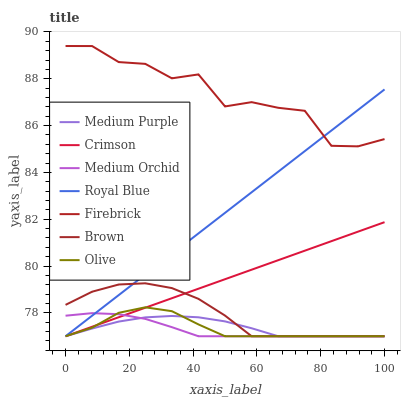Does Medium Orchid have the minimum area under the curve?
Answer yes or no. Yes. Does Firebrick have the maximum area under the curve?
Answer yes or no. Yes. Does Olive have the minimum area under the curve?
Answer yes or no. No. Does Olive have the maximum area under the curve?
Answer yes or no. No. Is Royal Blue the smoothest?
Answer yes or no. Yes. Is Firebrick the roughest?
Answer yes or no. Yes. Is Olive the smoothest?
Answer yes or no. No. Is Olive the roughest?
Answer yes or no. No. Does Brown have the lowest value?
Answer yes or no. Yes. Does Firebrick have the lowest value?
Answer yes or no. No. Does Firebrick have the highest value?
Answer yes or no. Yes. Does Olive have the highest value?
Answer yes or no. No. Is Medium Orchid less than Firebrick?
Answer yes or no. Yes. Is Firebrick greater than Brown?
Answer yes or no. Yes. Does Medium Orchid intersect Medium Purple?
Answer yes or no. Yes. Is Medium Orchid less than Medium Purple?
Answer yes or no. No. Is Medium Orchid greater than Medium Purple?
Answer yes or no. No. Does Medium Orchid intersect Firebrick?
Answer yes or no. No. 